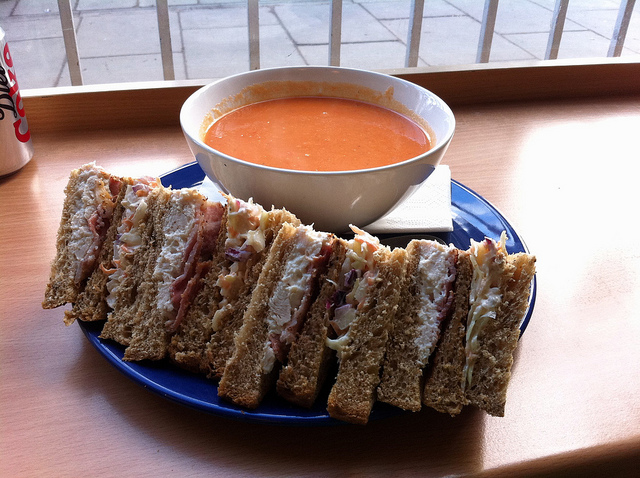How many brown horses are there? There are no brown horses in the image. The image shows a meal consisting of a sandwich cut into sections served alongside a bowl of tomato soup. 